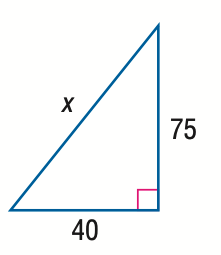Answer the mathemtical geometry problem and directly provide the correct option letter.
Question: Find x.
Choices: A: 80 B: 85 C: 90 D: 95 B 